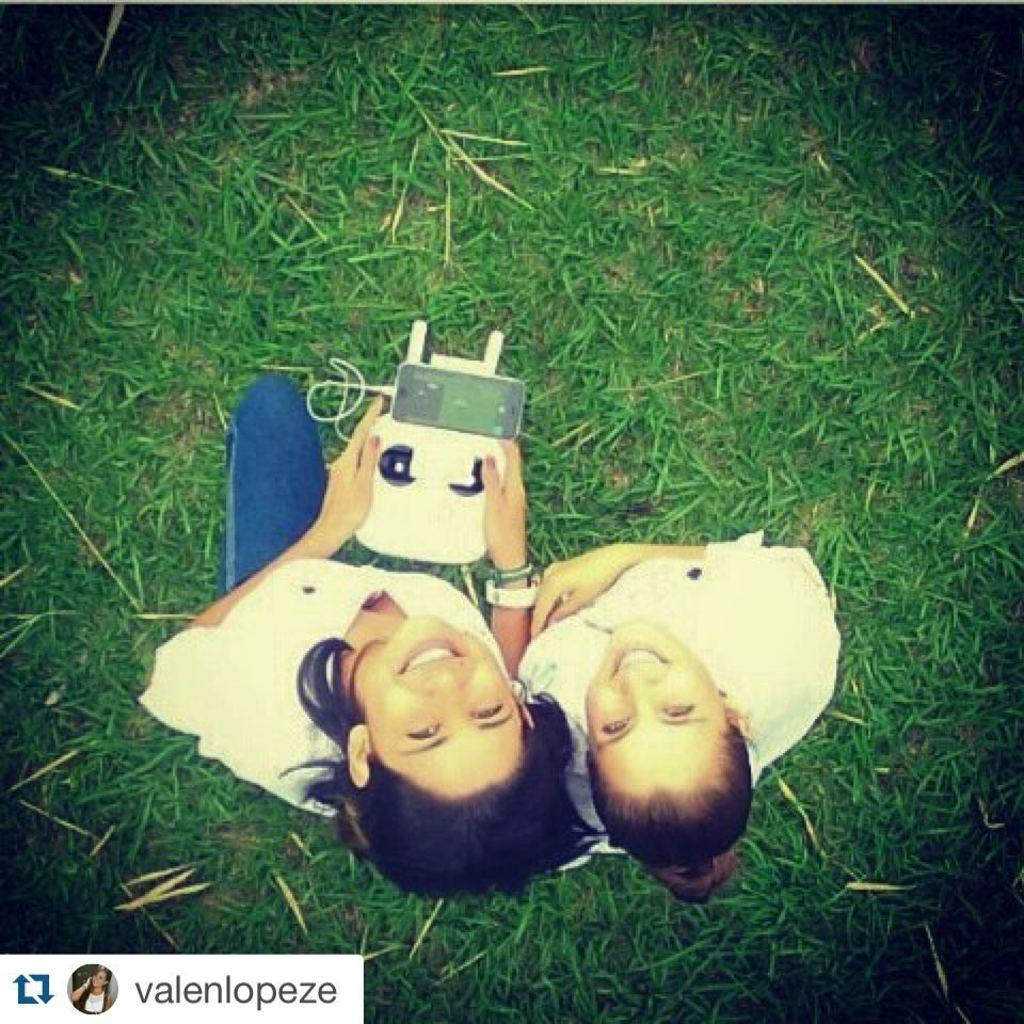How many people are in the foreground of the image? There are two women in the foreground of the image. What is the setting of the image? The women are on a grassy area. What is one of the women holding in her hand? One of the women is holding a gadget in her hand. What date is circled on the calendar in the image? There is no calendar present in the image. How many parcels can be seen in the image? There are no parcels visible in the image. 